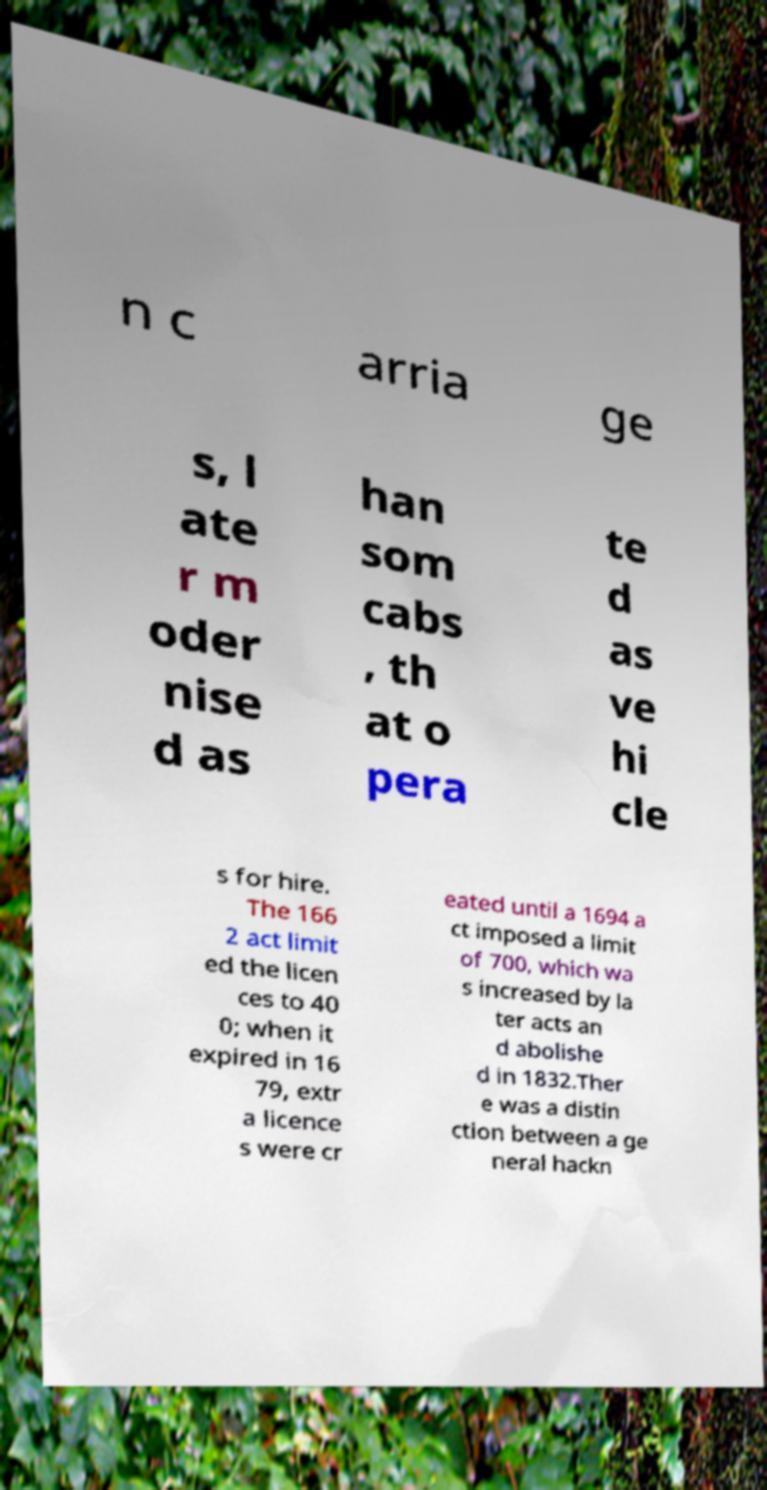There's text embedded in this image that I need extracted. Can you transcribe it verbatim? n c arria ge s, l ate r m oder nise d as han som cabs , th at o pera te d as ve hi cle s for hire. The 166 2 act limit ed the licen ces to 40 0; when it expired in 16 79, extr a licence s were cr eated until a 1694 a ct imposed a limit of 700, which wa s increased by la ter acts an d abolishe d in 1832.Ther e was a distin ction between a ge neral hackn 